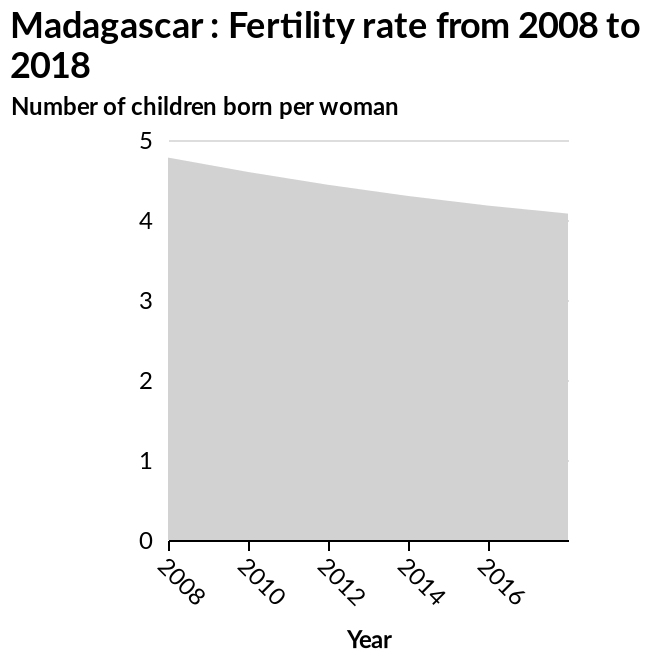<image>
please describe the details of the chart Here a area graph is called Madagascar : Fertility rate from 2008 to 2018. There is a linear scale with a minimum of 0 and a maximum of 5 along the y-axis, marked Number of children born per woman. A linear scale of range 2008 to 2016 can be seen along the x-axis, marked Year. How many children per person did the female fertility rates decrease by in Madagascar?  The female fertility rates in Madagascar decreased by 1 child per person, from 5 to 4, over the ten-year period from 2008 to 2018. please summary the statistics and relations of the chart From 2008 to 2018 female fertility rates have dropped in Madagascar from 5 children born per person to 4. A drop of 20% over a ten years period. 